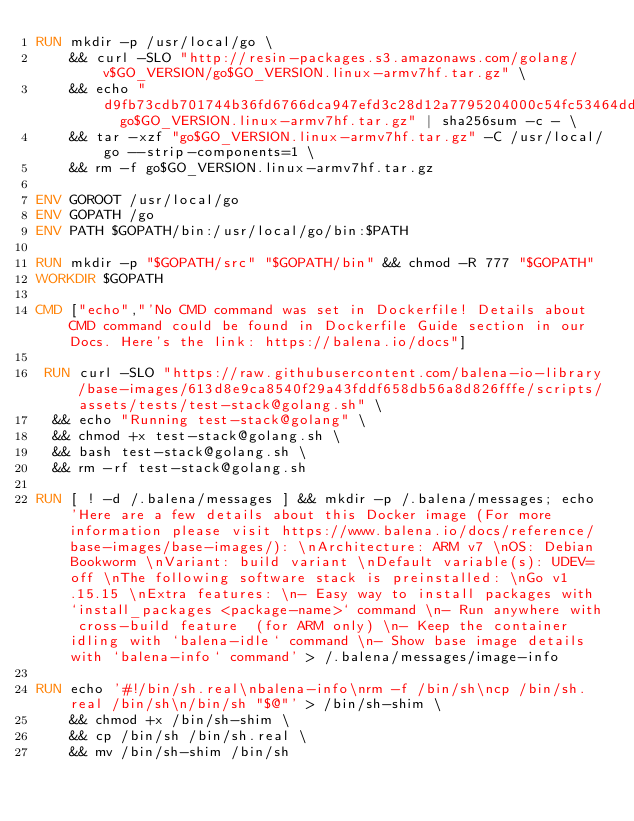Convert code to text. <code><loc_0><loc_0><loc_500><loc_500><_Dockerfile_>RUN mkdir -p /usr/local/go \
	&& curl -SLO "http://resin-packages.s3.amazonaws.com/golang/v$GO_VERSION/go$GO_VERSION.linux-armv7hf.tar.gz" \
	&& echo "d9fb73cdb701744b36fd6766dca947efd3c28d12a7795204000c54fc53464dde  go$GO_VERSION.linux-armv7hf.tar.gz" | sha256sum -c - \
	&& tar -xzf "go$GO_VERSION.linux-armv7hf.tar.gz" -C /usr/local/go --strip-components=1 \
	&& rm -f go$GO_VERSION.linux-armv7hf.tar.gz

ENV GOROOT /usr/local/go
ENV GOPATH /go
ENV PATH $GOPATH/bin:/usr/local/go/bin:$PATH

RUN mkdir -p "$GOPATH/src" "$GOPATH/bin" && chmod -R 777 "$GOPATH"
WORKDIR $GOPATH

CMD ["echo","'No CMD command was set in Dockerfile! Details about CMD command could be found in Dockerfile Guide section in our Docs. Here's the link: https://balena.io/docs"]

 RUN curl -SLO "https://raw.githubusercontent.com/balena-io-library/base-images/613d8e9ca8540f29a43fddf658db56a8d826fffe/scripts/assets/tests/test-stack@golang.sh" \
  && echo "Running test-stack@golang" \
  && chmod +x test-stack@golang.sh \
  && bash test-stack@golang.sh \
  && rm -rf test-stack@golang.sh 

RUN [ ! -d /.balena/messages ] && mkdir -p /.balena/messages; echo 'Here are a few details about this Docker image (For more information please visit https://www.balena.io/docs/reference/base-images/base-images/): \nArchitecture: ARM v7 \nOS: Debian Bookworm \nVariant: build variant \nDefault variable(s): UDEV=off \nThe following software stack is preinstalled: \nGo v1.15.15 \nExtra features: \n- Easy way to install packages with `install_packages <package-name>` command \n- Run anywhere with cross-build feature  (for ARM only) \n- Keep the container idling with `balena-idle` command \n- Show base image details with `balena-info` command' > /.balena/messages/image-info

RUN echo '#!/bin/sh.real\nbalena-info\nrm -f /bin/sh\ncp /bin/sh.real /bin/sh\n/bin/sh "$@"' > /bin/sh-shim \
	&& chmod +x /bin/sh-shim \
	&& cp /bin/sh /bin/sh.real \
	&& mv /bin/sh-shim /bin/sh</code> 